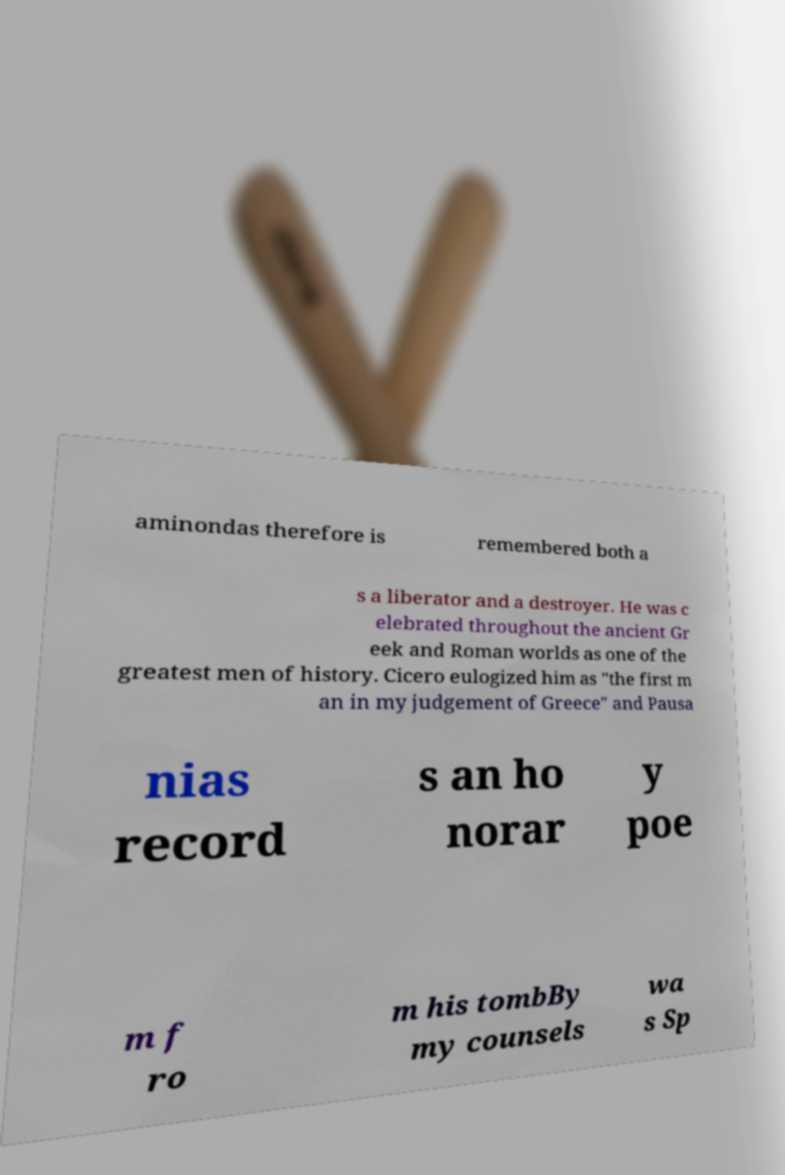For documentation purposes, I need the text within this image transcribed. Could you provide that? aminondas therefore is remembered both a s a liberator and a destroyer. He was c elebrated throughout the ancient Gr eek and Roman worlds as one of the greatest men of history. Cicero eulogized him as "the first m an in my judgement of Greece" and Pausa nias record s an ho norar y poe m f ro m his tombBy my counsels wa s Sp 